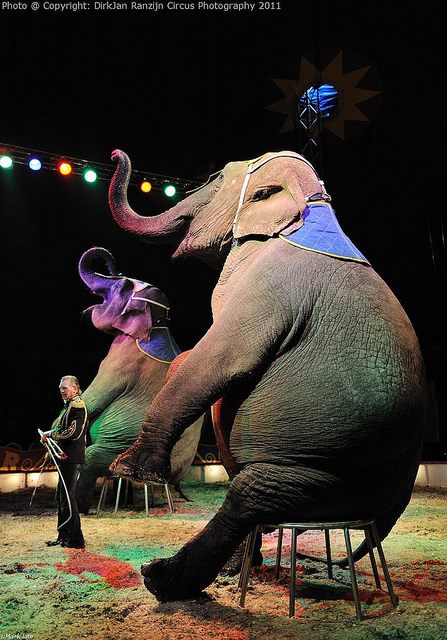Please extract the text content from this image. Photo 4 Copyright DirkJan Ranzijn Circus photography 2011 